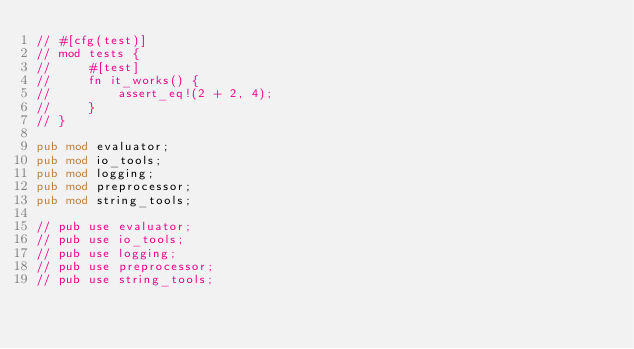<code> <loc_0><loc_0><loc_500><loc_500><_Rust_>// #[cfg(test)]
// mod tests {
//     #[test]
//     fn it_works() {
//         assert_eq!(2 + 2, 4);
//     }
// }

pub mod evaluator;
pub mod io_tools;
pub mod logging;
pub mod preprocessor;
pub mod string_tools;

// pub use evaluator;
// pub use io_tools;
// pub use logging;
// pub use preprocessor;
// pub use string_tools;
</code> 